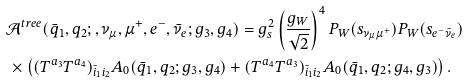<formula> <loc_0><loc_0><loc_500><loc_500>& \mathcal { A } ^ { t r e e } ( \bar { q } _ { 1 } , q _ { 2 } ; , \nu _ { \mu } , \mu ^ { + } , e ^ { - } , \bar { \nu } _ { e } ; g _ { 3 } , g _ { 4 } ) = g _ { s } ^ { 2 } \left ( \frac { g _ { W } } { \sqrt { 2 } } \right ) ^ { 4 } P _ { W } ( s _ { \nu _ { \mu } \mu ^ { + } } ) P _ { W } ( s _ { e ^ { - } \bar { \nu } _ { e } } ) \\ & \, \times \left ( ( T ^ { a _ { 3 } } T ^ { a _ { 4 } } ) _ { \bar { i } _ { 1 } i _ { 2 } } A _ { 0 } ( \bar { q } _ { 1 } , q _ { 2 } ; g _ { 3 } , g _ { 4 } ) + ( T ^ { a _ { 4 } } T ^ { a _ { 3 } } ) _ { \bar { i } _ { 1 } i _ { 2 } } A _ { 0 } ( \bar { q } _ { 1 } , q _ { 2 } ; g _ { 4 } , g _ { 3 } ) \right ) .</formula> 